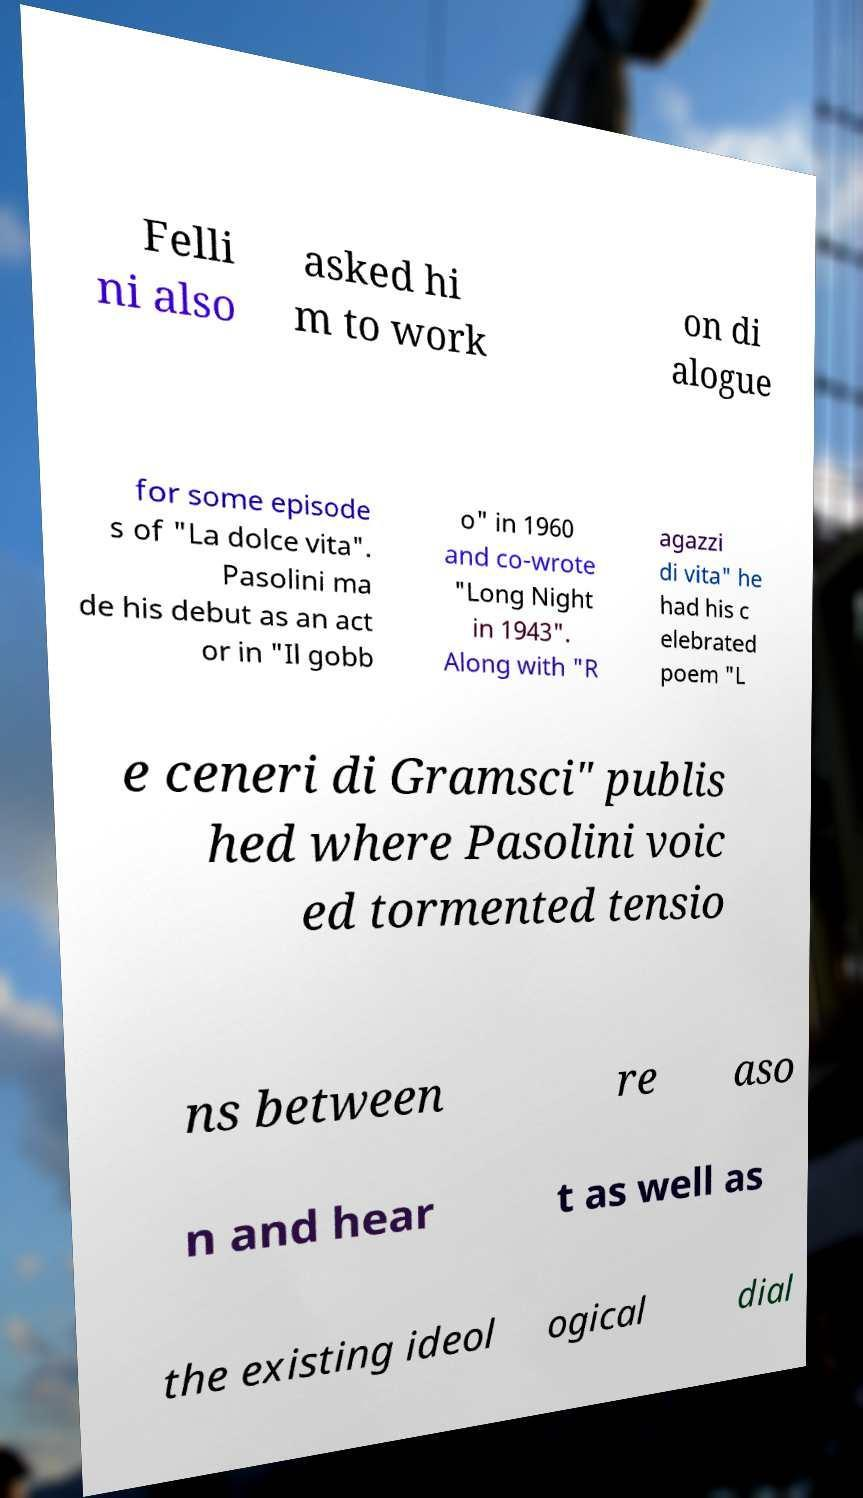Can you read and provide the text displayed in the image?This photo seems to have some interesting text. Can you extract and type it out for me? Felli ni also asked hi m to work on di alogue for some episode s of "La dolce vita". Pasolini ma de his debut as an act or in "Il gobb o" in 1960 and co-wrote "Long Night in 1943". Along with "R agazzi di vita" he had his c elebrated poem "L e ceneri di Gramsci" publis hed where Pasolini voic ed tormented tensio ns between re aso n and hear t as well as the existing ideol ogical dial 